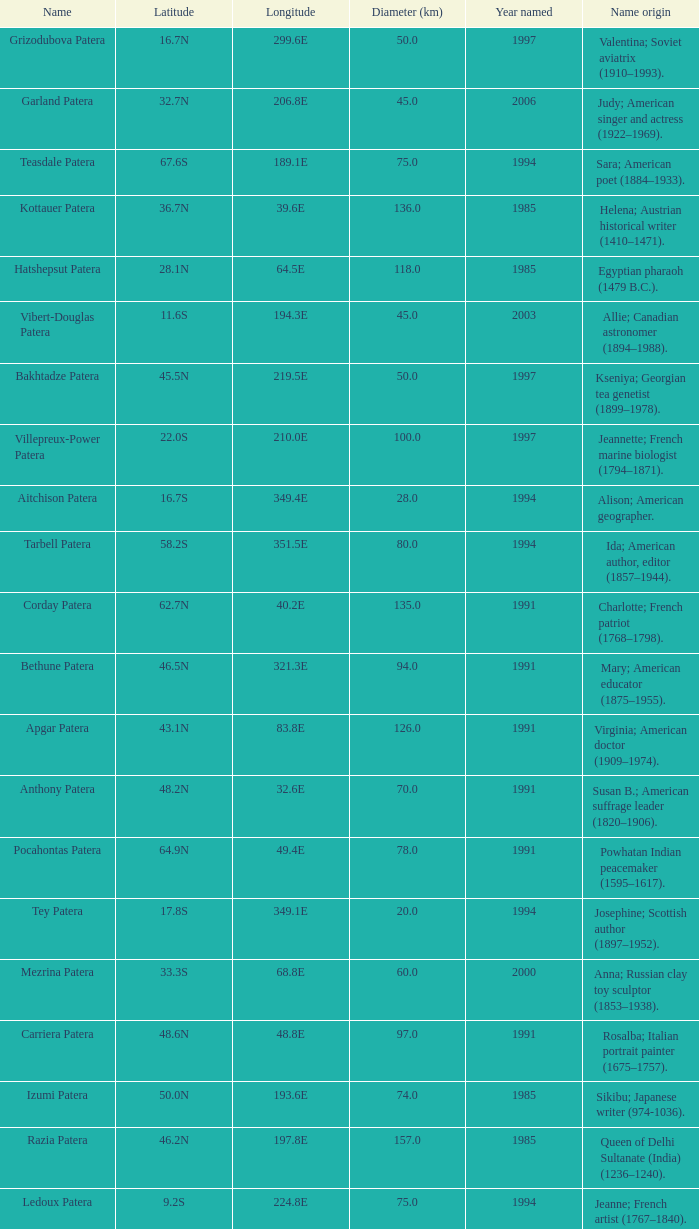What is the longitude of the feature named Razia Patera?  197.8E. 